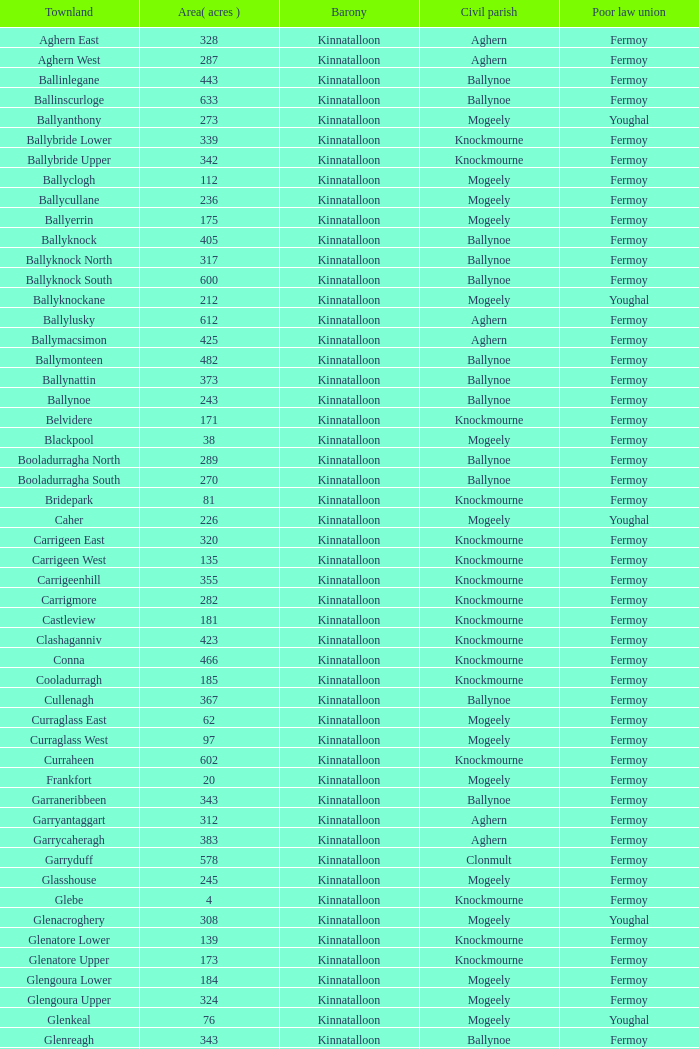Identify the civil parish for garryduff. Clonmult. 